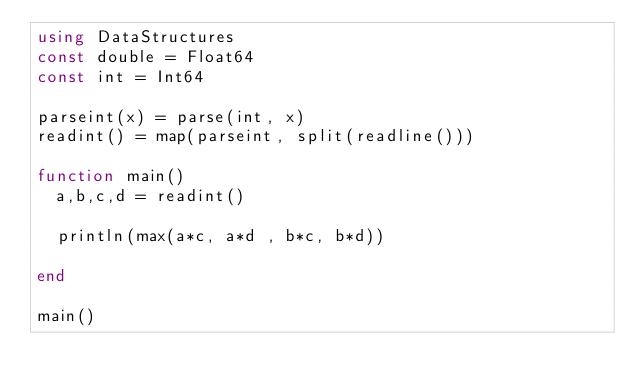Convert code to text. <code><loc_0><loc_0><loc_500><loc_500><_Julia_>using DataStructures
const double = Float64
const int = Int64

parseint(x) = parse(int, x)
readint() = map(parseint, split(readline()))

function main()
  a,b,c,d = readint()
  
  println(max(a*c, a*d , b*c, b*d))

end

main()
</code> 